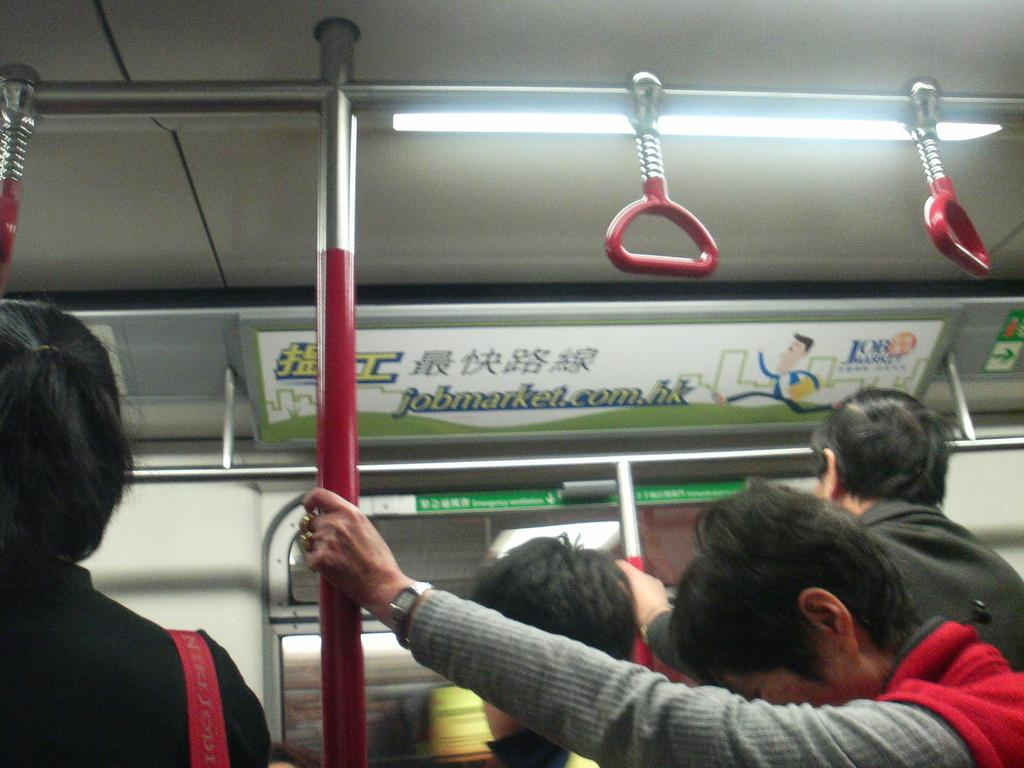What is the main subject of the image? There is a vehicle in the image. Can you describe the people in the image? There are people in the image, and one of them is holding a rod. What is located at the top of the image? There are boards at the top of the image. What feature is visible in the image that might be used for support? Strap hangers are visible in the image. Is there any source of illumination in the image? Yes, there is a light in the image. How many locks can be seen on the hands of the person holding the rod in the image? There are no locks visible on the hands of the person holding the rod in the image. What type of button is being pushed by the person holding the rod in the image? There is no button being pushed by the person holding the rod in the image. 